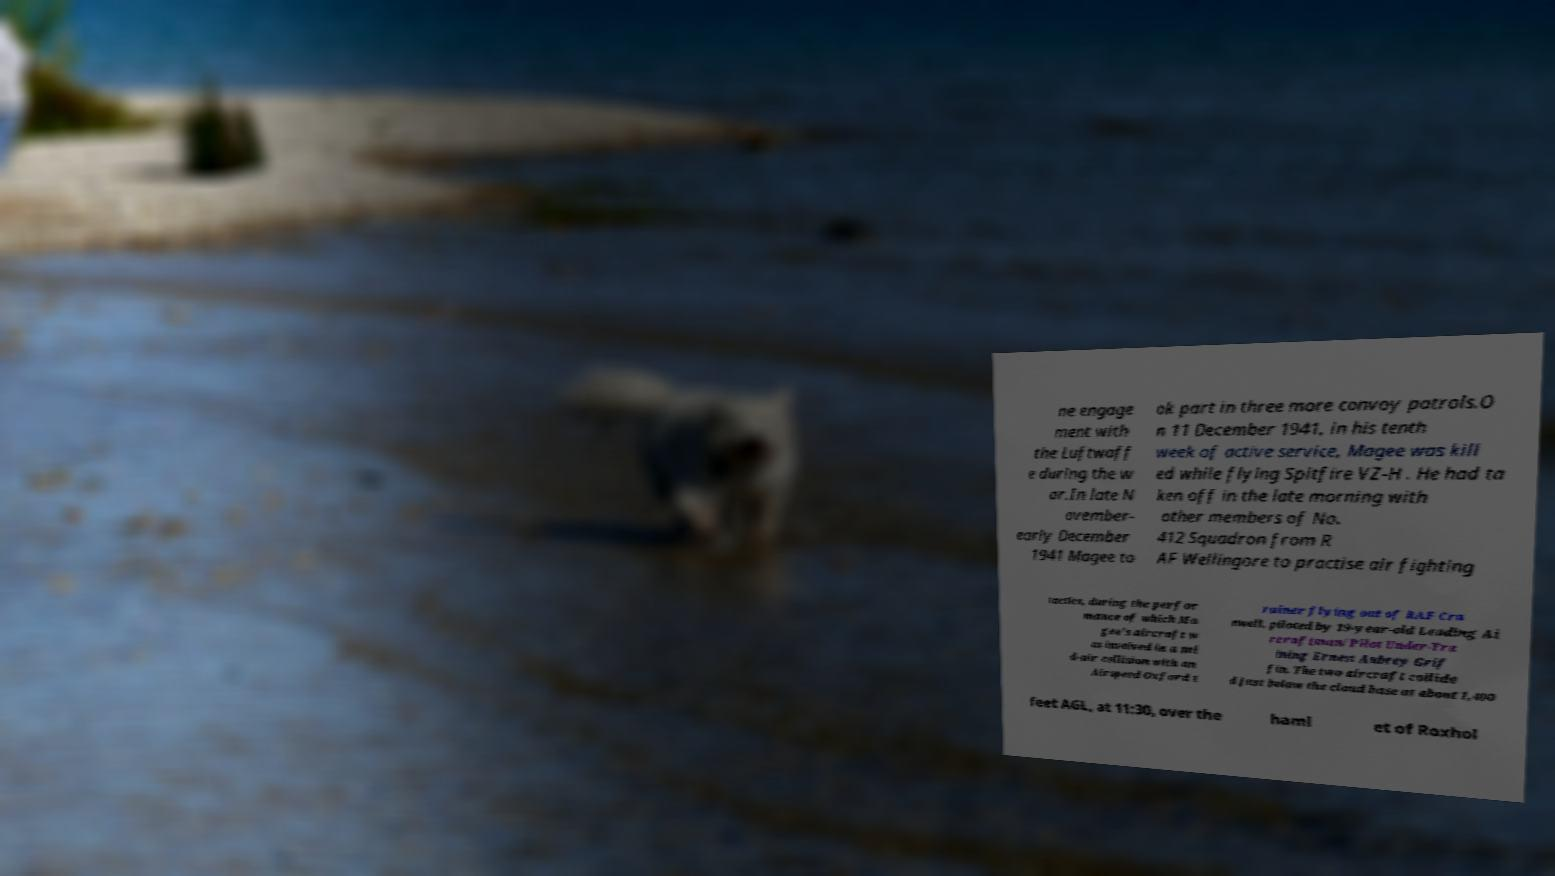Please identify and transcribe the text found in this image. ne engage ment with the Luftwaff e during the w ar.In late N ovember- early December 1941 Magee to ok part in three more convoy patrols.O n 11 December 1941, in his tenth week of active service, Magee was kill ed while flying Spitfire VZ-H . He had ta ken off in the late morning with other members of No. 412 Squadron from R AF Wellingore to practise air fighting tactics, during the perfor mance of which Ma gee's aircraft w as involved in a mi d-air collision with an Airspeed Oxford t rainer flying out of RAF Cra nwell, piloted by 19-year-old Leading Ai rcraftman/Pilot Under-Tra ining Ernest Aubrey Grif fin. The two aircraft collide d just below the cloud base at about 1,400 feet AGL, at 11:30, over the haml et of Roxhol 